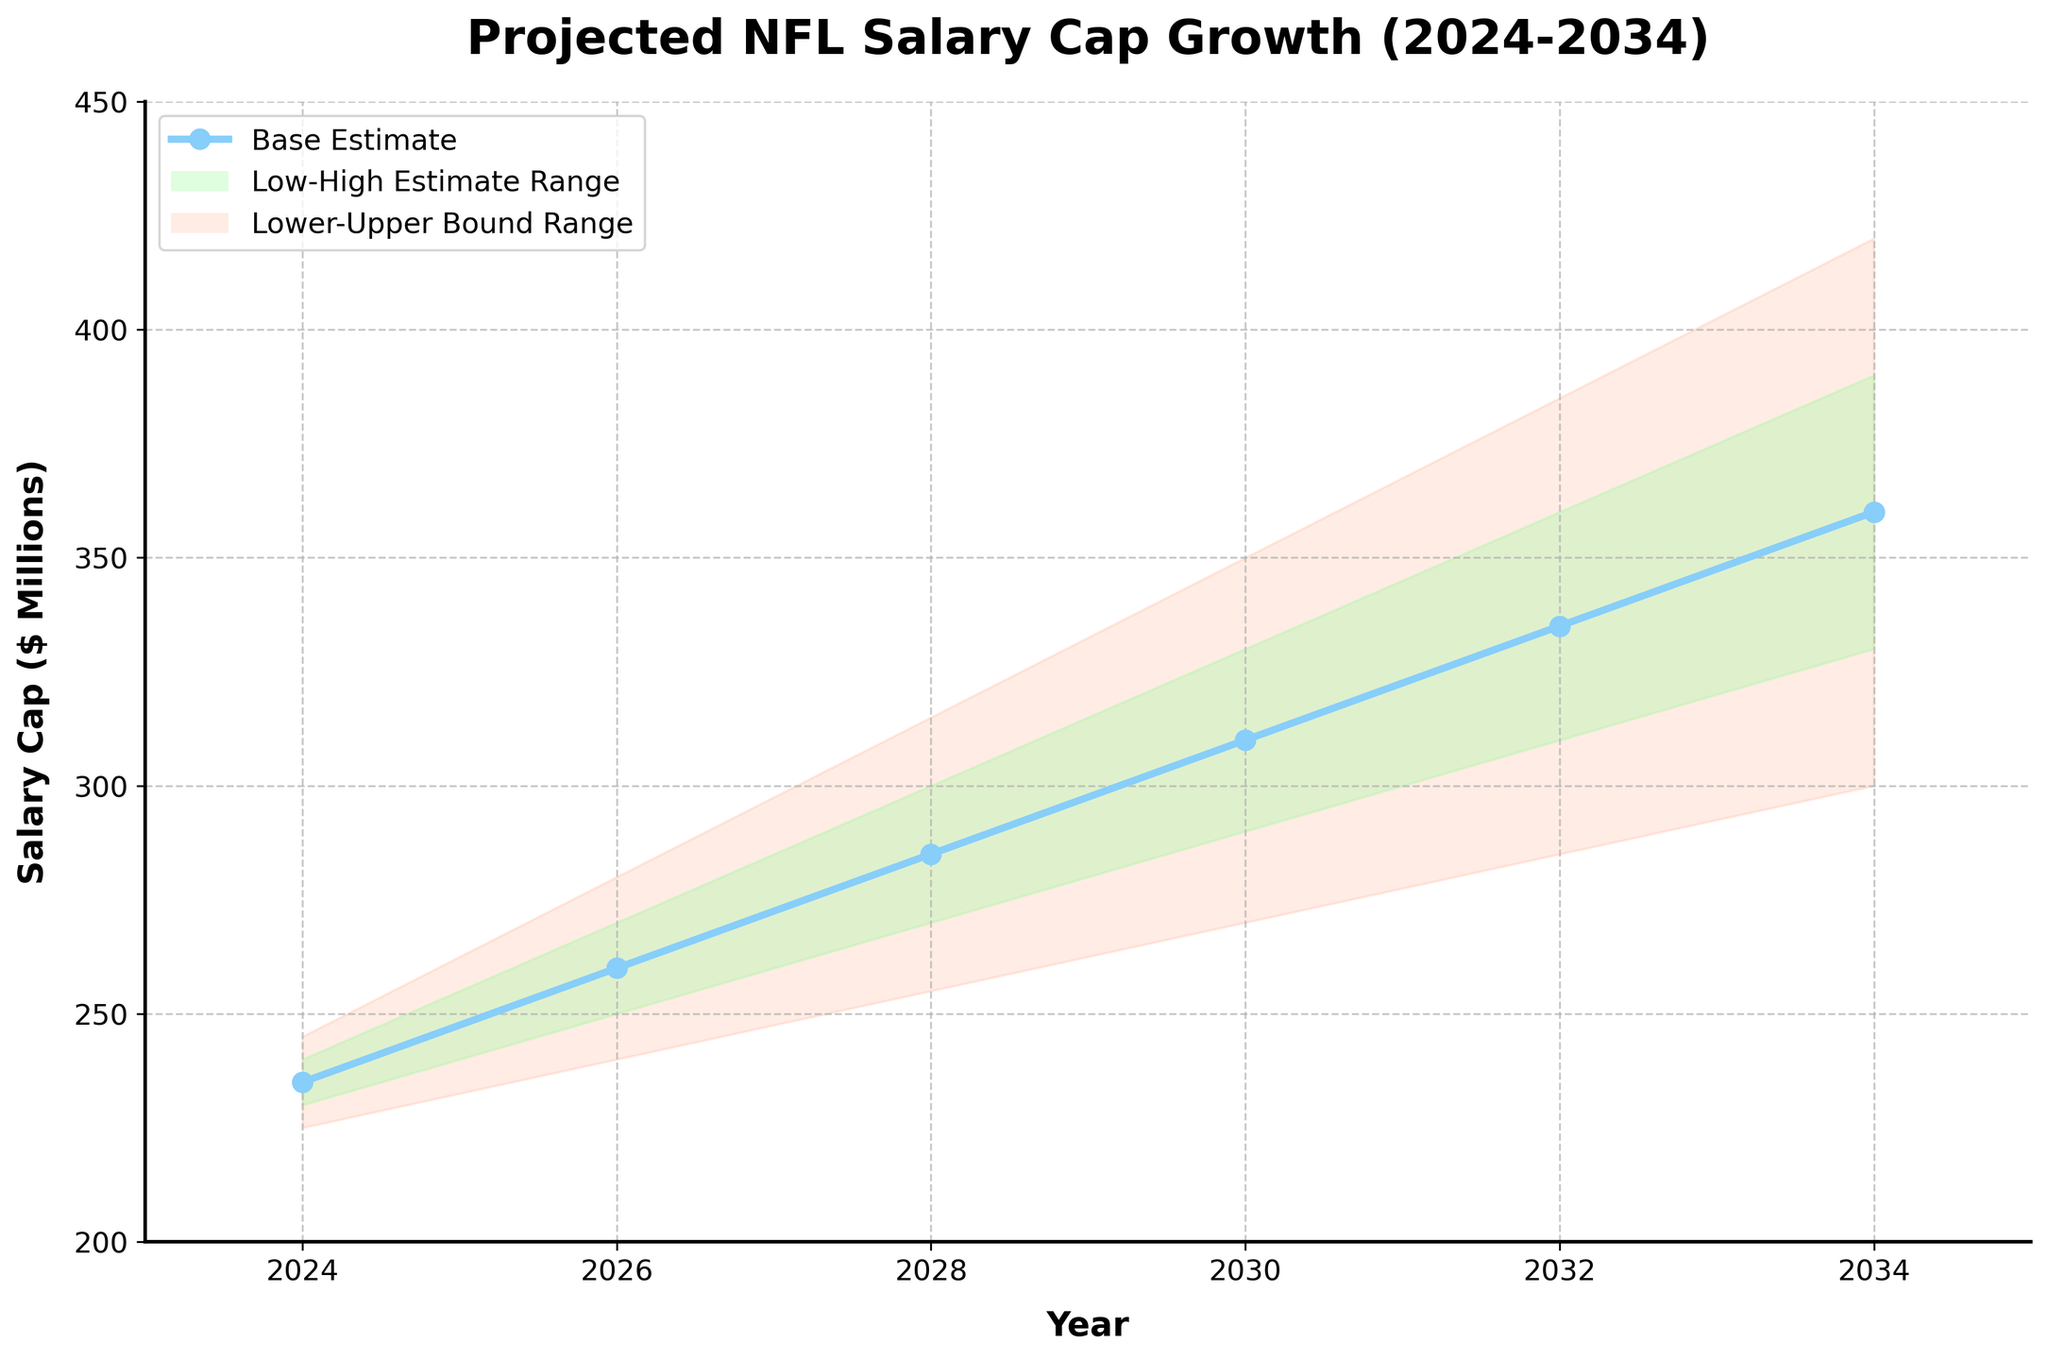How many years are displayed in the figure? The figure shows the salary cap projections for each year from 2024 to 2034. To find the total number of years, list all the years: 2024, 2026, 2028, 2030, 2032, and 2034. There are 6 years in total.
Answer: 6 What is the title of the figure? The title of the figure is displayed at the top of the plot. It reads: "Projected NFL Salary Cap Growth (2024-2034)".
Answer: Projected NFL Salary Cap Growth (2024-2034) What is the range of the Upper Bound in 2034? The Upper Bound in 2034 is shown at the top of the fan chart for the year 2034. The corresponding value from the data table is 420 million dollars.
Answer: 420 million dollars What is the base estimate for the salary cap in 2028? Look along the line labeled "Base Estimate" for the year 2028. The base estimate value from the table is 285 million dollars.
Answer: 285 million dollars What is the difference between the Lower Bound and the Upper Bound in 2024? The Lower Bound in 2024 is 225 million dollars, and the Upper Bound in 2024 is 245 million dollars. Subtract the Lower Bound from the Upper Bound: 245 - 225 = 20 million dollars.
Answer: 20 million dollars How does the Base Estimate change from 2024 to 2034? The Base Estimate in 2024 is 235 million dollars, and the Base Estimate in 2034 is 360 million dollars. To find the change, subtract the 2024 value from the 2034 value: 360 - 235 = 125 million dollars.
Answer: 125 million dollars Which year shows the largest increase in the High Estimate compared to the previous year? The High Estimate increases between each pair of consecutive years shown. Calculate the increase for each pair:
2024 to 2026: 270 - 240 = 30
2026 to 2028: 300 - 270 = 30
2028 to 2030: 330 - 300 = 30
2030 to 2032: 360 - 330 = 30
2032 to 2034: 390 - 360 = 30.
Each interval shows an equal increase of 30 million dollars, so each subsequent year shows an equal increase.
Answer: Equal increase each year What is the average salary cap estimate for the year 2030 across all scenarios? To find the average, sum all the estimates for the year 2030 and divide by the number of estimates. The estimates for 2030 are 270, 290, 310, 330, 350. The sum is 270 + 290 + 310 + 330 + 350 = 1550. Divide by 5: 1550 / 5 = 310 million dollars.
Answer: 310 million dollars What is the projected range of the salary cap for 2028? The range extends from the Lower Bound to the Upper Bound for the year 2028. These values are 255 million dollars and 315 million dollars, respectively. Therefore, the range is from 255 to 315 million dollars.
Answer: 255 to 315 million dollars 